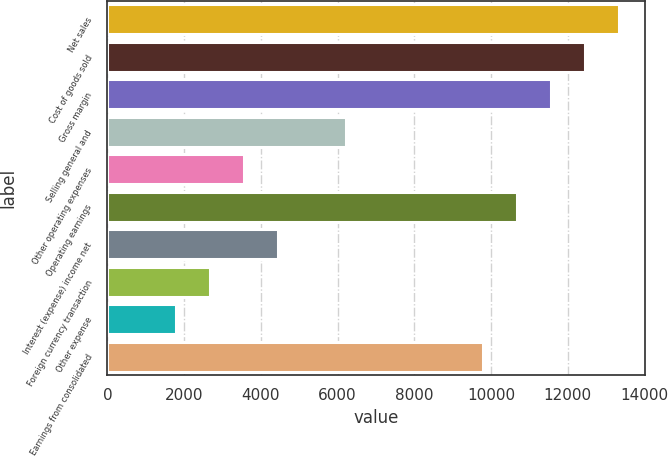Convert chart. <chart><loc_0><loc_0><loc_500><loc_500><bar_chart><fcel>Net sales<fcel>Cost of goods sold<fcel>Gross margin<fcel>Selling general and<fcel>Other operating expenses<fcel>Operating earnings<fcel>Interest (expense) income net<fcel>Foreign currency transaction<fcel>Other expense<fcel>Earnings from consolidated<nl><fcel>13342.2<fcel>12452.9<fcel>11563.5<fcel>6227.13<fcel>3558.96<fcel>10674.1<fcel>4448.35<fcel>2669.57<fcel>1780.18<fcel>9784.69<nl></chart> 